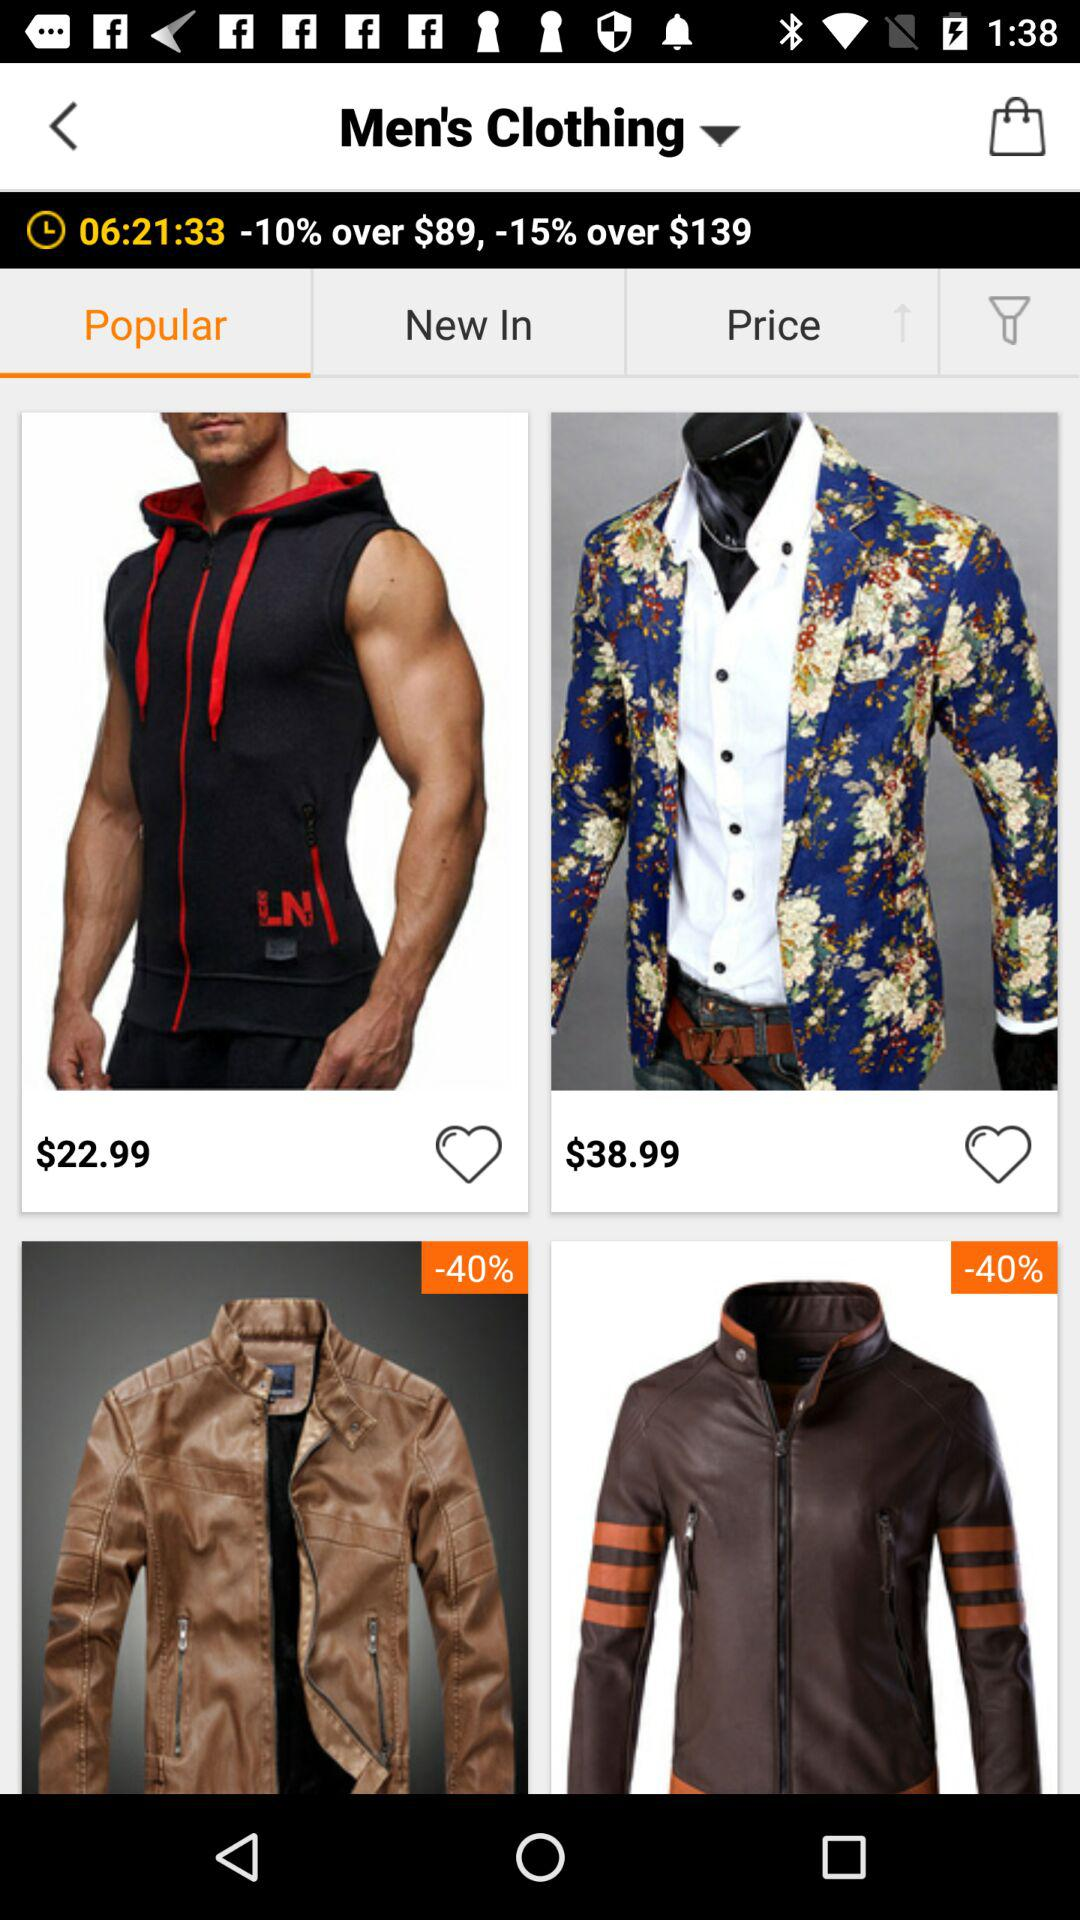How much discount will we get on shopping for $89 or more? You will get a discount of 10% on shopping for $89 or more. 